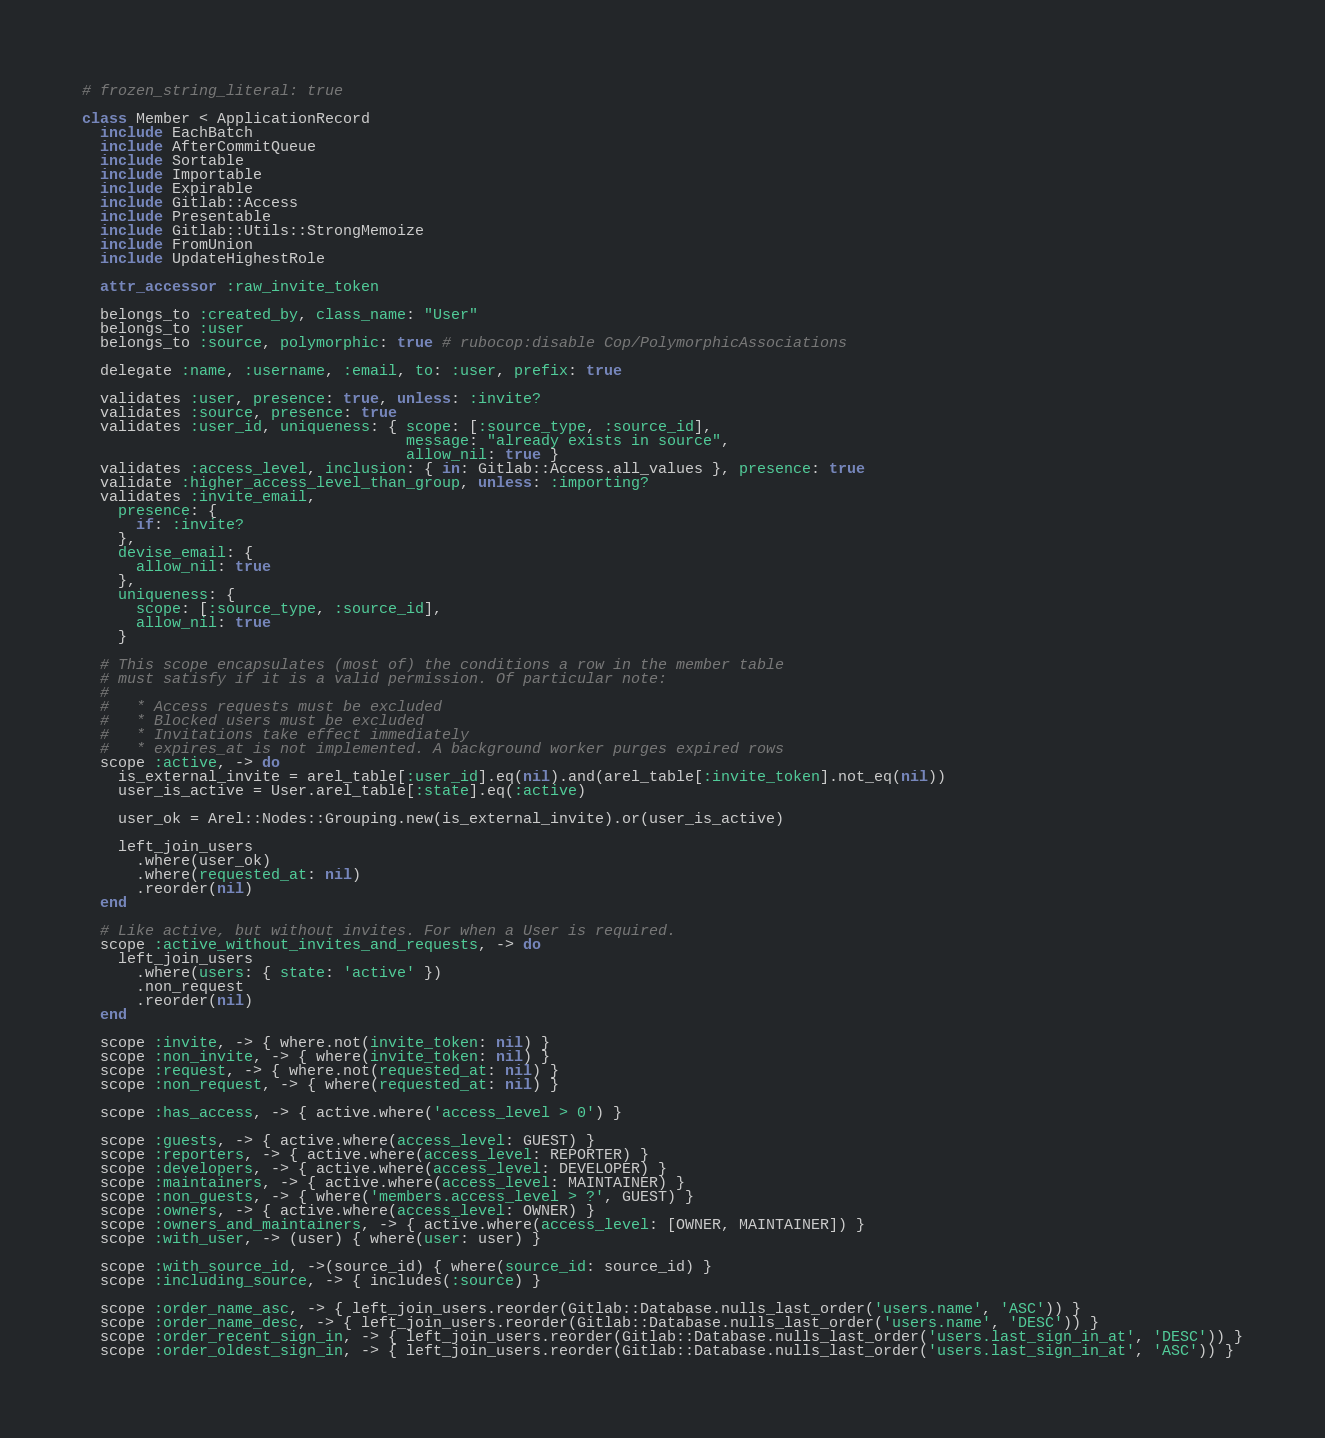<code> <loc_0><loc_0><loc_500><loc_500><_Ruby_># frozen_string_literal: true

class Member < ApplicationRecord
  include EachBatch
  include AfterCommitQueue
  include Sortable
  include Importable
  include Expirable
  include Gitlab::Access
  include Presentable
  include Gitlab::Utils::StrongMemoize
  include FromUnion
  include UpdateHighestRole

  attr_accessor :raw_invite_token

  belongs_to :created_by, class_name: "User"
  belongs_to :user
  belongs_to :source, polymorphic: true # rubocop:disable Cop/PolymorphicAssociations

  delegate :name, :username, :email, to: :user, prefix: true

  validates :user, presence: true, unless: :invite?
  validates :source, presence: true
  validates :user_id, uniqueness: { scope: [:source_type, :source_id],
                                    message: "already exists in source",
                                    allow_nil: true }
  validates :access_level, inclusion: { in: Gitlab::Access.all_values }, presence: true
  validate :higher_access_level_than_group, unless: :importing?
  validates :invite_email,
    presence: {
      if: :invite?
    },
    devise_email: {
      allow_nil: true
    },
    uniqueness: {
      scope: [:source_type, :source_id],
      allow_nil: true
    }

  # This scope encapsulates (most of) the conditions a row in the member table
  # must satisfy if it is a valid permission. Of particular note:
  #
  #   * Access requests must be excluded
  #   * Blocked users must be excluded
  #   * Invitations take effect immediately
  #   * expires_at is not implemented. A background worker purges expired rows
  scope :active, -> do
    is_external_invite = arel_table[:user_id].eq(nil).and(arel_table[:invite_token].not_eq(nil))
    user_is_active = User.arel_table[:state].eq(:active)

    user_ok = Arel::Nodes::Grouping.new(is_external_invite).or(user_is_active)

    left_join_users
      .where(user_ok)
      .where(requested_at: nil)
      .reorder(nil)
  end

  # Like active, but without invites. For when a User is required.
  scope :active_without_invites_and_requests, -> do
    left_join_users
      .where(users: { state: 'active' })
      .non_request
      .reorder(nil)
  end

  scope :invite, -> { where.not(invite_token: nil) }
  scope :non_invite, -> { where(invite_token: nil) }
  scope :request, -> { where.not(requested_at: nil) }
  scope :non_request, -> { where(requested_at: nil) }

  scope :has_access, -> { active.where('access_level > 0') }

  scope :guests, -> { active.where(access_level: GUEST) }
  scope :reporters, -> { active.where(access_level: REPORTER) }
  scope :developers, -> { active.where(access_level: DEVELOPER) }
  scope :maintainers, -> { active.where(access_level: MAINTAINER) }
  scope :non_guests, -> { where('members.access_level > ?', GUEST) }
  scope :owners, -> { active.where(access_level: OWNER) }
  scope :owners_and_maintainers, -> { active.where(access_level: [OWNER, MAINTAINER]) }
  scope :with_user, -> (user) { where(user: user) }

  scope :with_source_id, ->(source_id) { where(source_id: source_id) }
  scope :including_source, -> { includes(:source) }

  scope :order_name_asc, -> { left_join_users.reorder(Gitlab::Database.nulls_last_order('users.name', 'ASC')) }
  scope :order_name_desc, -> { left_join_users.reorder(Gitlab::Database.nulls_last_order('users.name', 'DESC')) }
  scope :order_recent_sign_in, -> { left_join_users.reorder(Gitlab::Database.nulls_last_order('users.last_sign_in_at', 'DESC')) }
  scope :order_oldest_sign_in, -> { left_join_users.reorder(Gitlab::Database.nulls_last_order('users.last_sign_in_at', 'ASC')) }
</code> 